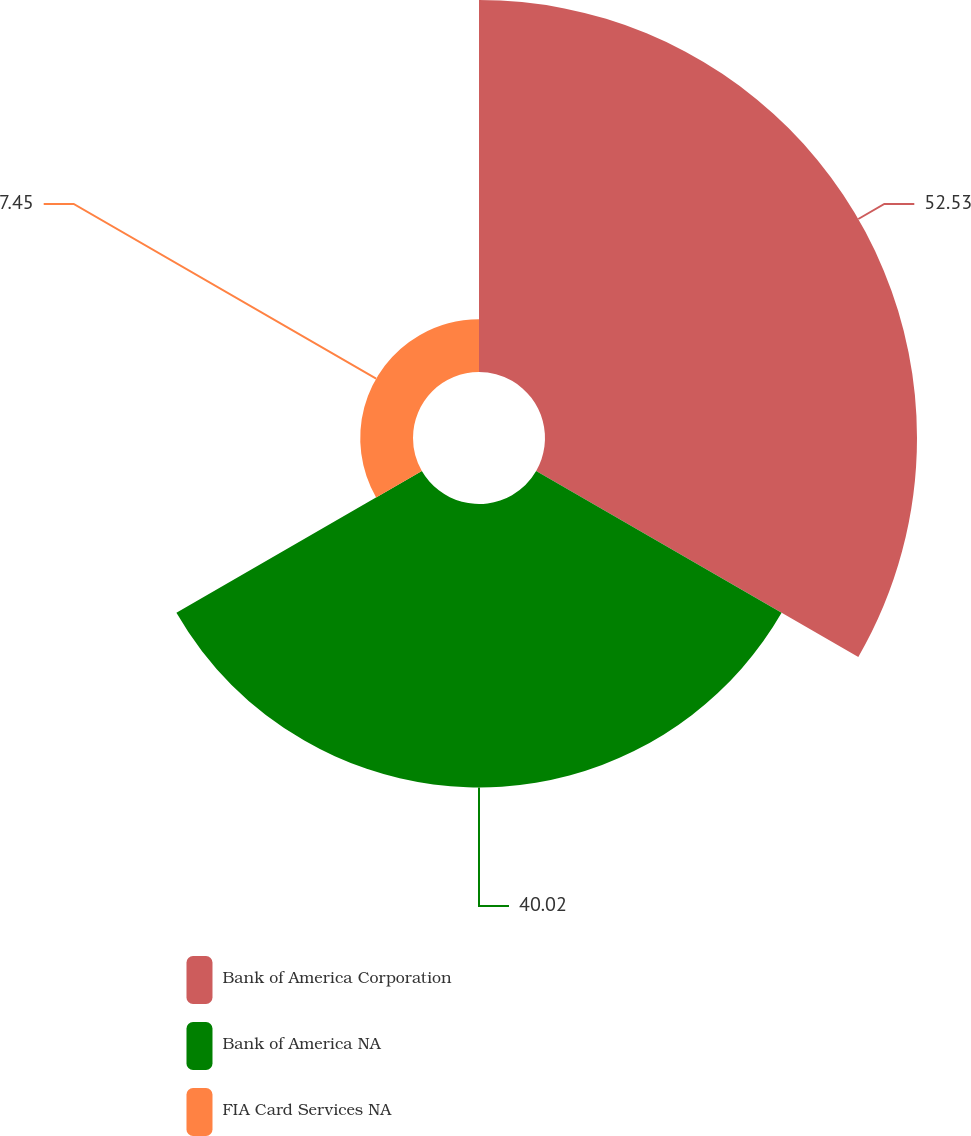<chart> <loc_0><loc_0><loc_500><loc_500><pie_chart><fcel>Bank of America Corporation<fcel>Bank of America NA<fcel>FIA Card Services NA<nl><fcel>52.53%<fcel>40.02%<fcel>7.45%<nl></chart> 